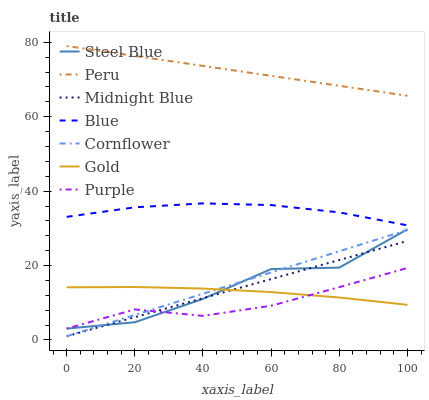Does Cornflower have the minimum area under the curve?
Answer yes or no. No. Does Cornflower have the maximum area under the curve?
Answer yes or no. No. Is Cornflower the smoothest?
Answer yes or no. No. Is Cornflower the roughest?
Answer yes or no. No. Does Gold have the lowest value?
Answer yes or no. No. Does Cornflower have the highest value?
Answer yes or no. No. Is Cornflower less than Blue?
Answer yes or no. Yes. Is Blue greater than Gold?
Answer yes or no. Yes. Does Cornflower intersect Blue?
Answer yes or no. No. 